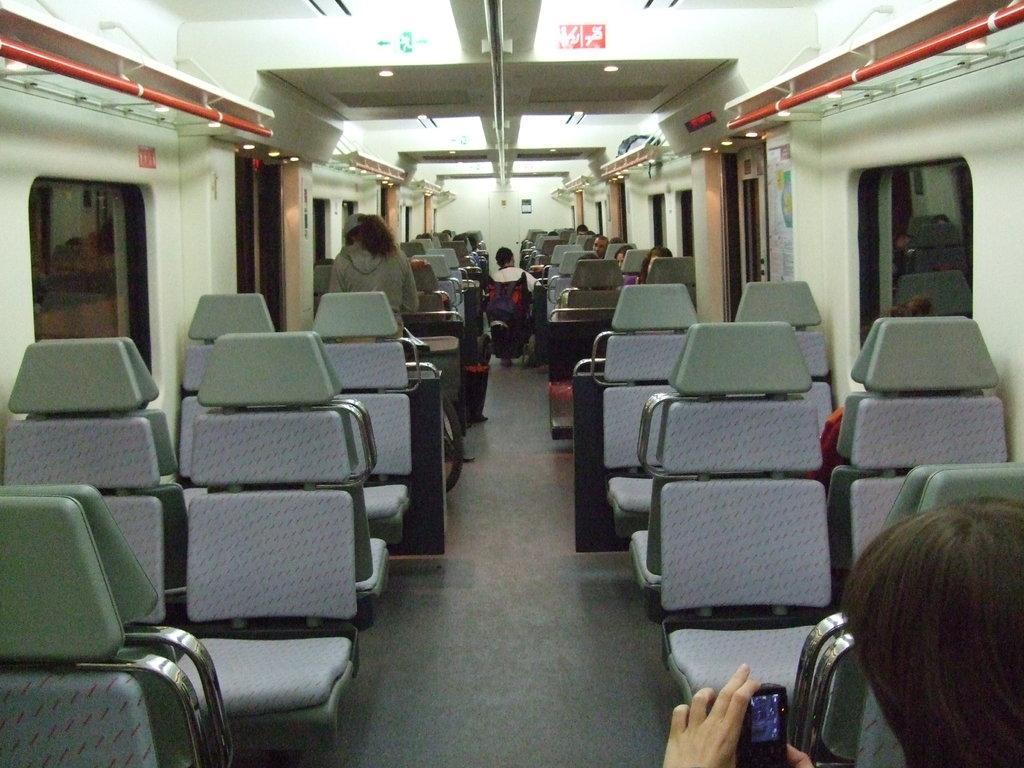Describe this image in one or two sentences. This image is taken inside the train. In this image there are a few people sitting in their seats, one of them is standing and on the right bottom side of the image there is a person holding a mobile. On the left and right side of the image there are windows and doors. At the top of the image there are lights, rods and few sign boards. 